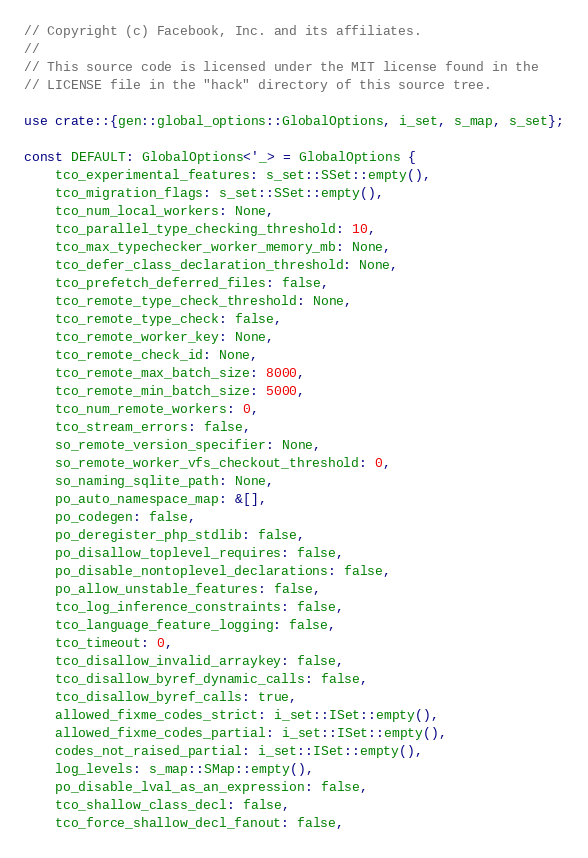<code> <loc_0><loc_0><loc_500><loc_500><_Rust_>// Copyright (c) Facebook, Inc. and its affiliates.
//
// This source code is licensed under the MIT license found in the
// LICENSE file in the "hack" directory of this source tree.

use crate::{gen::global_options::GlobalOptions, i_set, s_map, s_set};

const DEFAULT: GlobalOptions<'_> = GlobalOptions {
    tco_experimental_features: s_set::SSet::empty(),
    tco_migration_flags: s_set::SSet::empty(),
    tco_num_local_workers: None,
    tco_parallel_type_checking_threshold: 10,
    tco_max_typechecker_worker_memory_mb: None,
    tco_defer_class_declaration_threshold: None,
    tco_prefetch_deferred_files: false,
    tco_remote_type_check_threshold: None,
    tco_remote_type_check: false,
    tco_remote_worker_key: None,
    tco_remote_check_id: None,
    tco_remote_max_batch_size: 8000,
    tco_remote_min_batch_size: 5000,
    tco_num_remote_workers: 0,
    tco_stream_errors: false,
    so_remote_version_specifier: None,
    so_remote_worker_vfs_checkout_threshold: 0,
    so_naming_sqlite_path: None,
    po_auto_namespace_map: &[],
    po_codegen: false,
    po_deregister_php_stdlib: false,
    po_disallow_toplevel_requires: false,
    po_disable_nontoplevel_declarations: false,
    po_allow_unstable_features: false,
    tco_log_inference_constraints: false,
    tco_language_feature_logging: false,
    tco_timeout: 0,
    tco_disallow_invalid_arraykey: false,
    tco_disallow_byref_dynamic_calls: false,
    tco_disallow_byref_calls: true,
    allowed_fixme_codes_strict: i_set::ISet::empty(),
    allowed_fixme_codes_partial: i_set::ISet::empty(),
    codes_not_raised_partial: i_set::ISet::empty(),
    log_levels: s_map::SMap::empty(),
    po_disable_lval_as_an_expression: false,
    tco_shallow_class_decl: false,
    tco_force_shallow_decl_fanout: false,</code> 